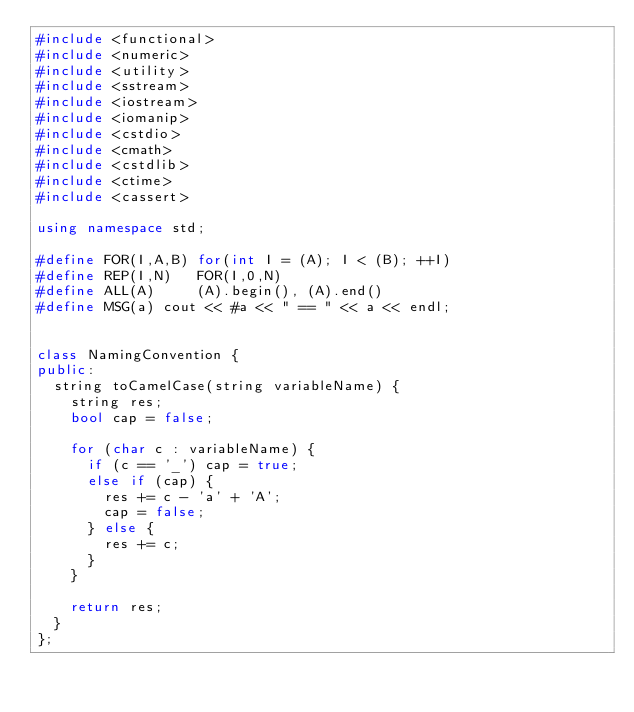<code> <loc_0><loc_0><loc_500><loc_500><_C++_>#include <functional>
#include <numeric>
#include <utility>
#include <sstream>
#include <iostream>
#include <iomanip>
#include <cstdio>
#include <cmath>
#include <cstdlib>
#include <ctime>
#include <cassert>

using namespace std;

#define FOR(I,A,B) for(int I = (A); I < (B); ++I)
#define REP(I,N)   FOR(I,0,N)
#define ALL(A)     (A).begin(), (A).end()
#define MSG(a) cout << #a << " == " << a << endl;


class NamingConvention {
public:
  string toCamelCase(string variableName) {
    string res;
    bool cap = false;

    for (char c : variableName) {
      if (c == '_') cap = true;
      else if (cap) {
        res += c - 'a' + 'A';
        cap = false;
      } else {
        res += c;
      }
    }

    return res;
  }
};
</code> 